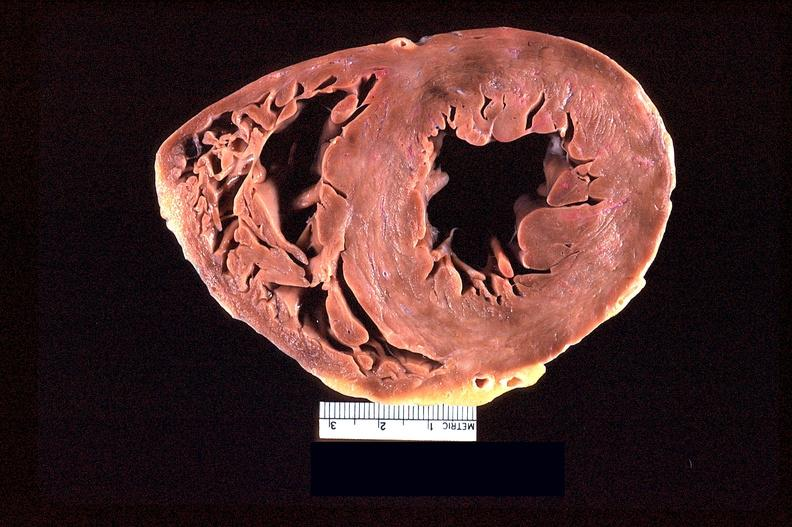s cardiovascular present?
Answer the question using a single word or phrase. Yes 